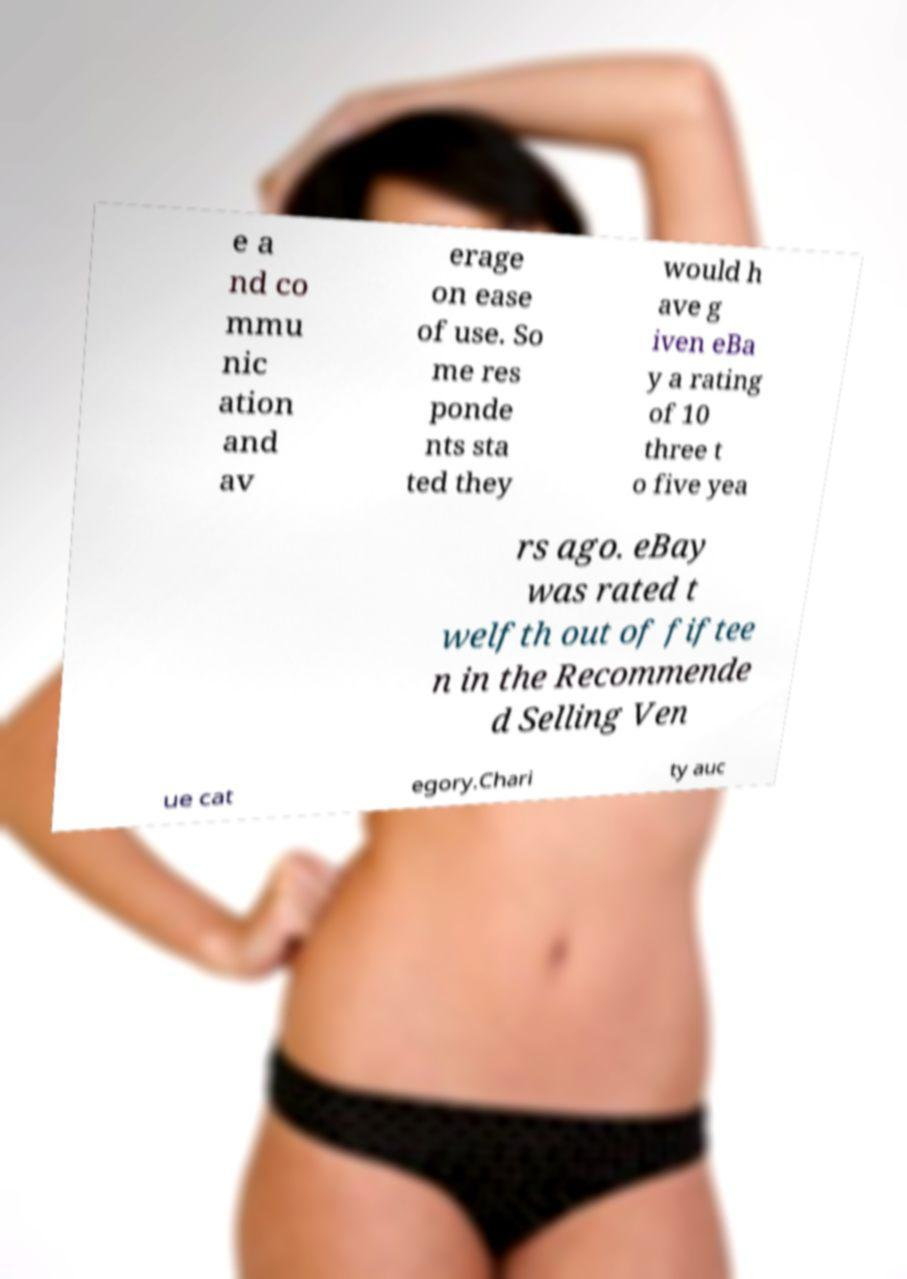For documentation purposes, I need the text within this image transcribed. Could you provide that? e a nd co mmu nic ation and av erage on ease of use. So me res ponde nts sta ted they would h ave g iven eBa y a rating of 10 three t o five yea rs ago. eBay was rated t welfth out of fiftee n in the Recommende d Selling Ven ue cat egory.Chari ty auc 